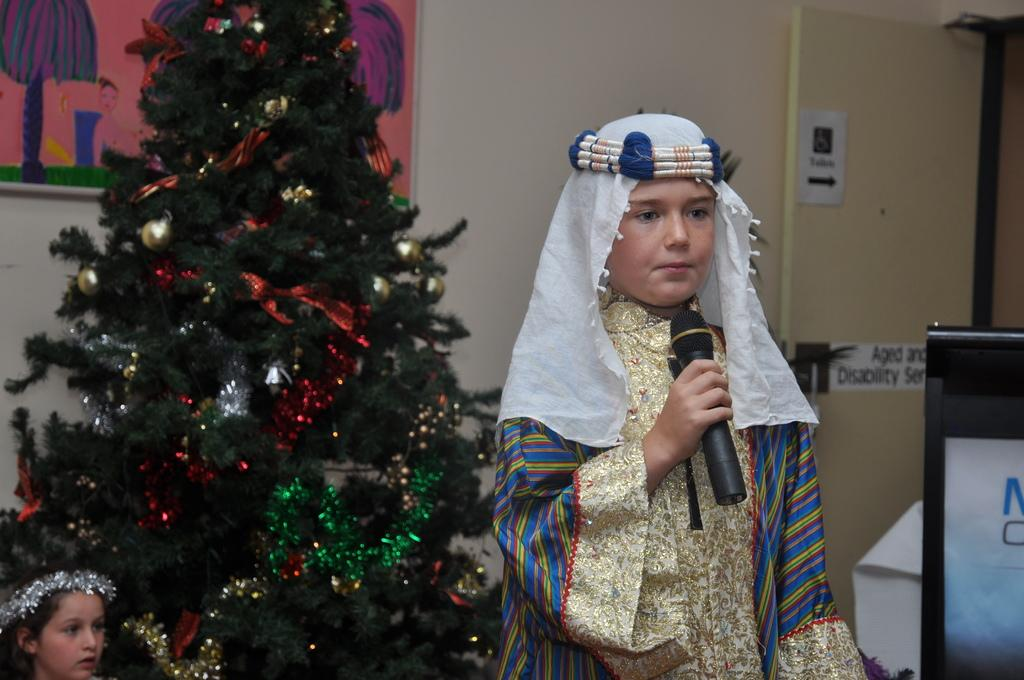What is the person in the image holding? The person is holding a microphone in the image. What can be seen on the left side of the image? There is a Christmas tree on the left side of the image. What type of juice is being served at the division meeting in the image? There is no division meeting or juice present in the image. 